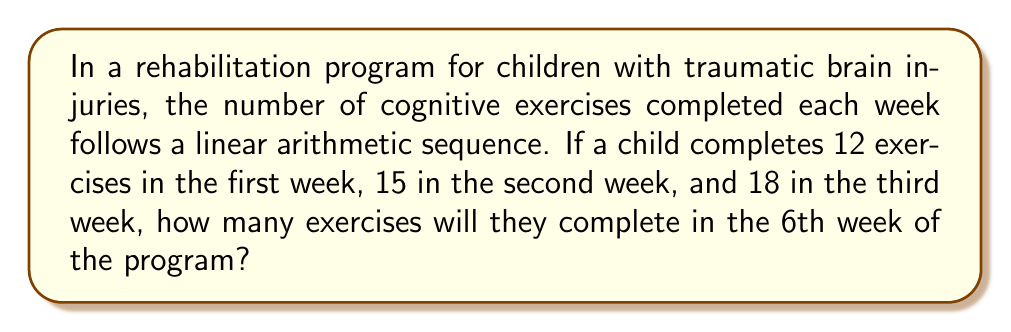Show me your answer to this math problem. Let's approach this step-by-step:

1) First, we need to identify the pattern in the sequence. We're given:
   Week 1: 12 exercises
   Week 2: 15 exercises
   Week 3: 18 exercises

2) To find the common difference (d) in this arithmetic sequence:
   $d = 15 - 12 = 18 - 15 = 3$

3) We can express the sequence using the formula:
   $a_n = a_1 + (n-1)d$
   Where $a_n$ is the nth term, $a_1$ is the first term, n is the position, and d is the common difference.

4) We want to find the 6th term ($a_6$), so we plug in our values:
   $a_6 = 12 + (6-1)3$

5) Simplify:
   $a_6 = 12 + (5)(3)$
   $a_6 = 12 + 15$
   $a_6 = 27$

Therefore, in the 6th week, the child will complete 27 exercises.
Answer: 27 